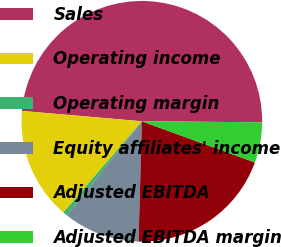Convert chart. <chart><loc_0><loc_0><loc_500><loc_500><pie_chart><fcel>Sales<fcel>Operating income<fcel>Operating margin<fcel>Equity affiliates' income<fcel>Adjusted EBITDA<fcel>Adjusted EBITDA margin<nl><fcel>48.77%<fcel>15.06%<fcel>0.62%<fcel>10.25%<fcel>19.88%<fcel>5.43%<nl></chart> 